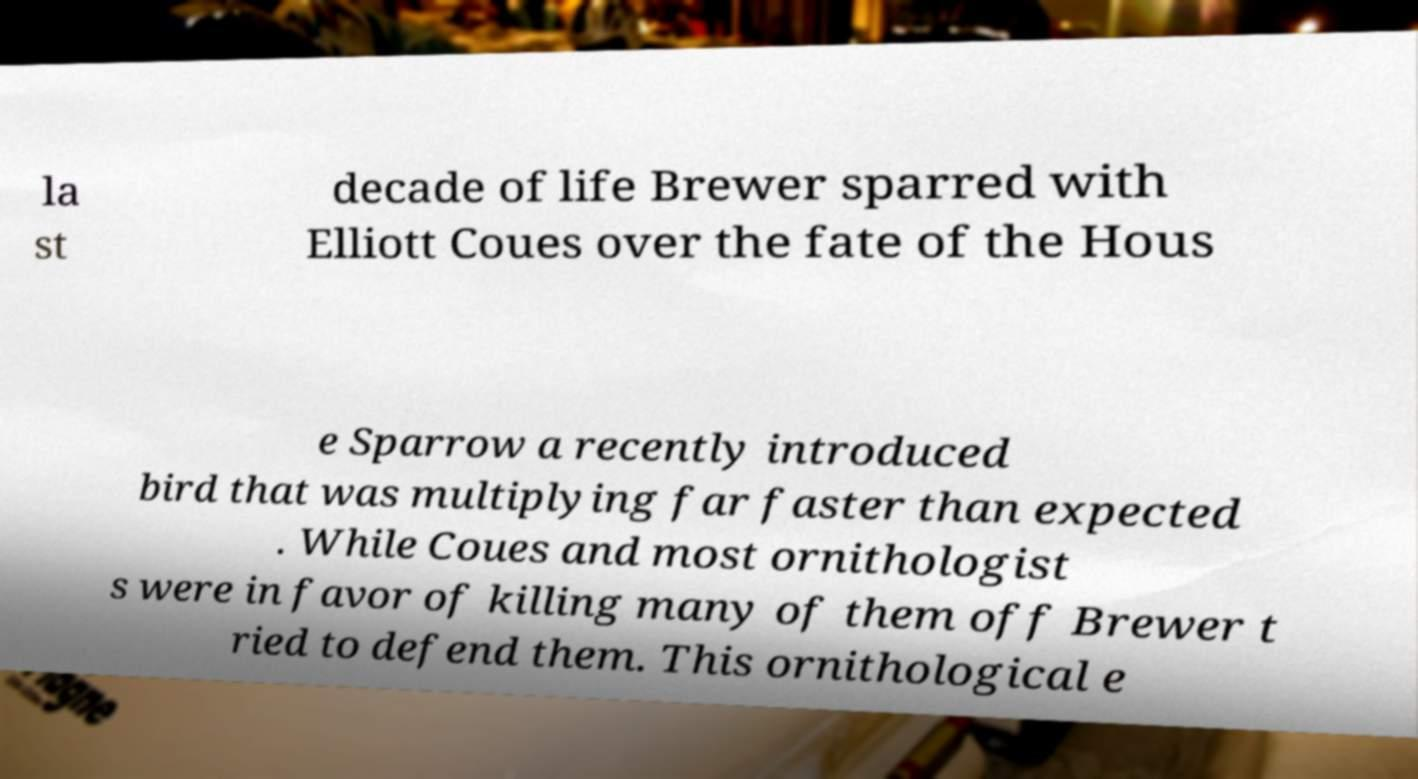Can you read and provide the text displayed in the image?This photo seems to have some interesting text. Can you extract and type it out for me? la st decade of life Brewer sparred with Elliott Coues over the fate of the Hous e Sparrow a recently introduced bird that was multiplying far faster than expected . While Coues and most ornithologist s were in favor of killing many of them off Brewer t ried to defend them. This ornithological e 